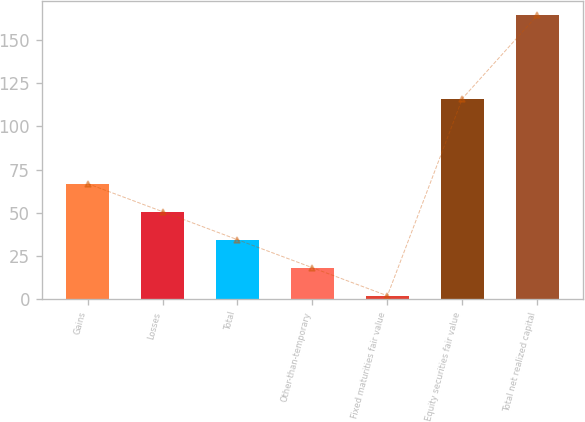Convert chart. <chart><loc_0><loc_0><loc_500><loc_500><bar_chart><fcel>Gains<fcel>Losses<fcel>Total<fcel>Other-than-temporary<fcel>Fixed maturities fair value<fcel>Equity securities fair value<fcel>Total net realized capital<nl><fcel>66.9<fcel>50.65<fcel>34.4<fcel>18.15<fcel>1.9<fcel>116.2<fcel>164.4<nl></chart> 